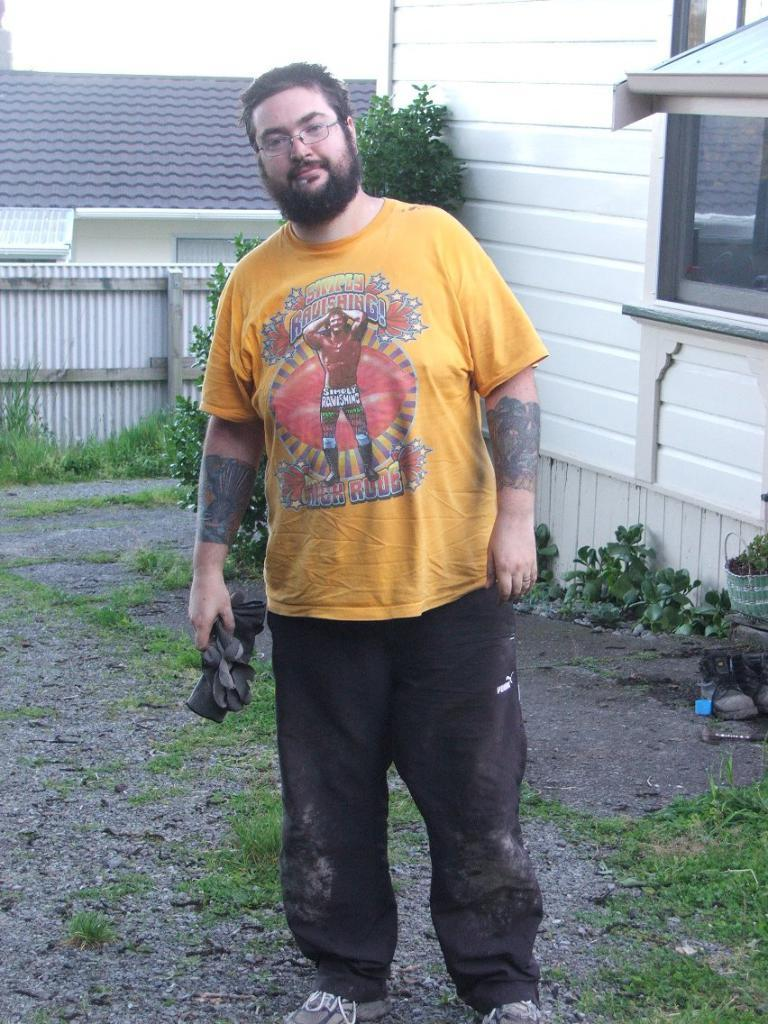What is the person in the image doing? The person is standing in the image. What is the person holding in the image? The person is holding an object. What can be seen in the background of the image? There are plants, a tree, a railing, and the sky visible in the background of the image. What type of form is the person filling out in the image? There is no form present in the image; the person is simply standing and holding an object. Can you see any flames in the image? There are no flames present in the image. 